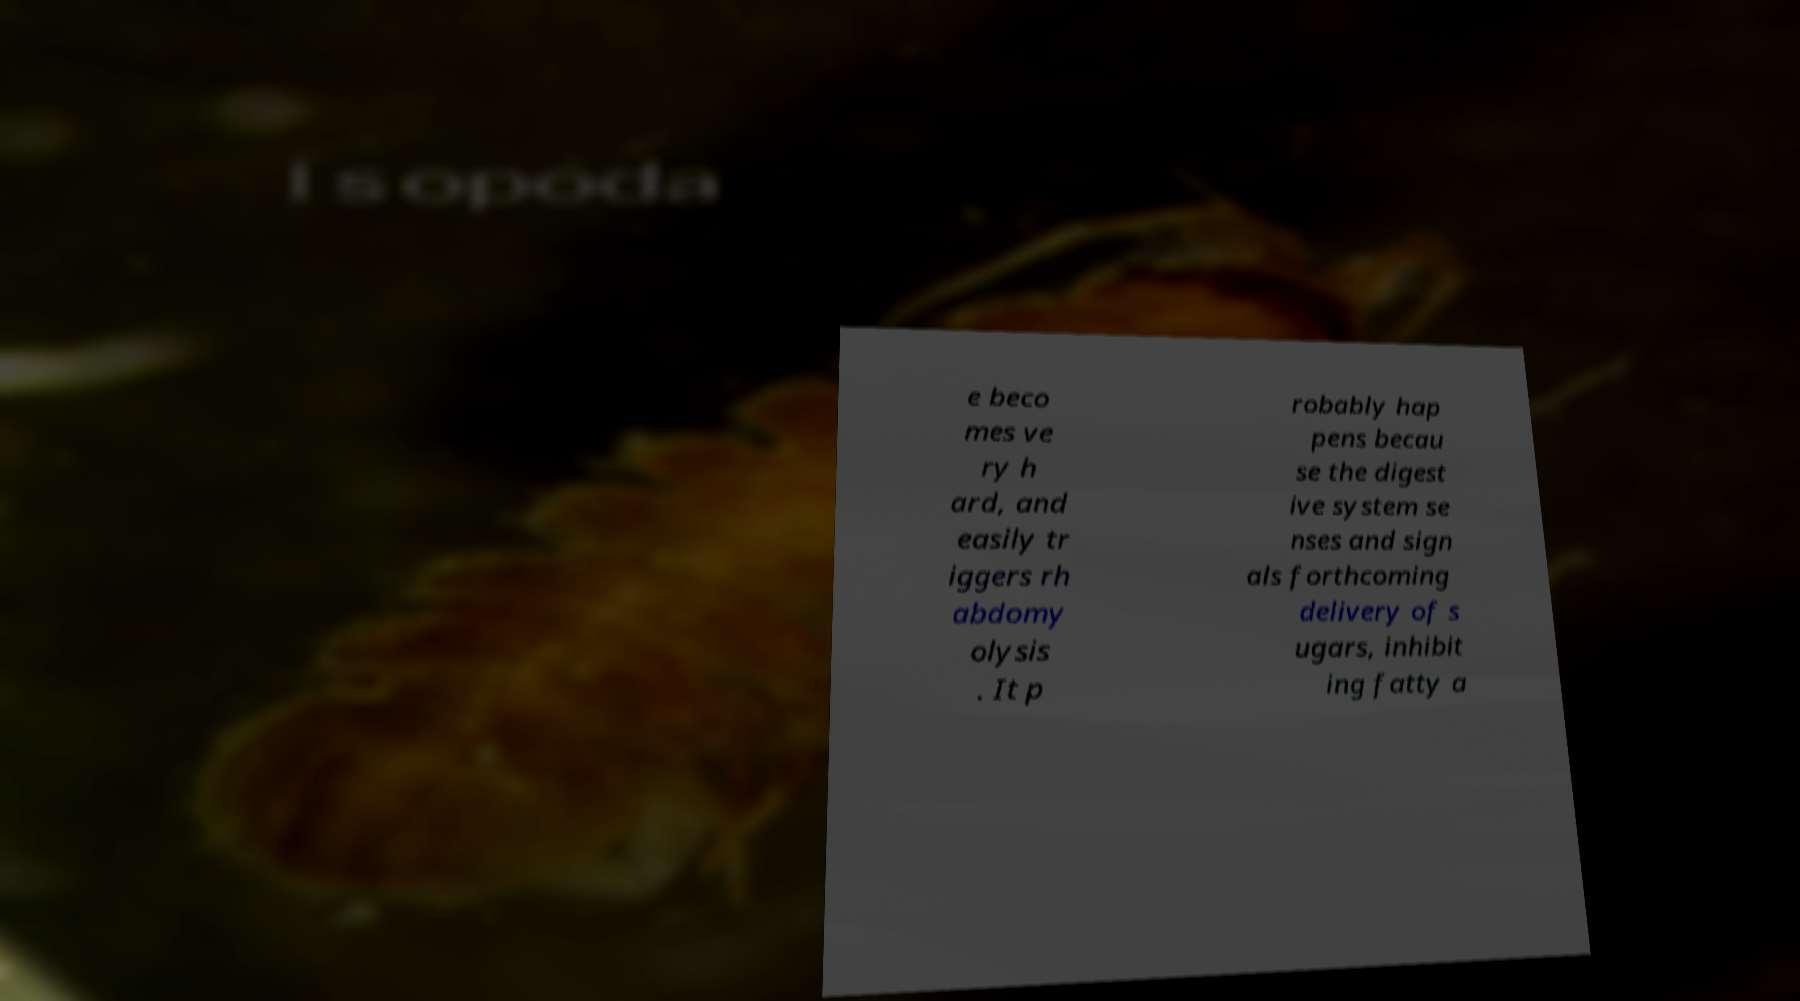Could you assist in decoding the text presented in this image and type it out clearly? e beco mes ve ry h ard, and easily tr iggers rh abdomy olysis . It p robably hap pens becau se the digest ive system se nses and sign als forthcoming delivery of s ugars, inhibit ing fatty a 